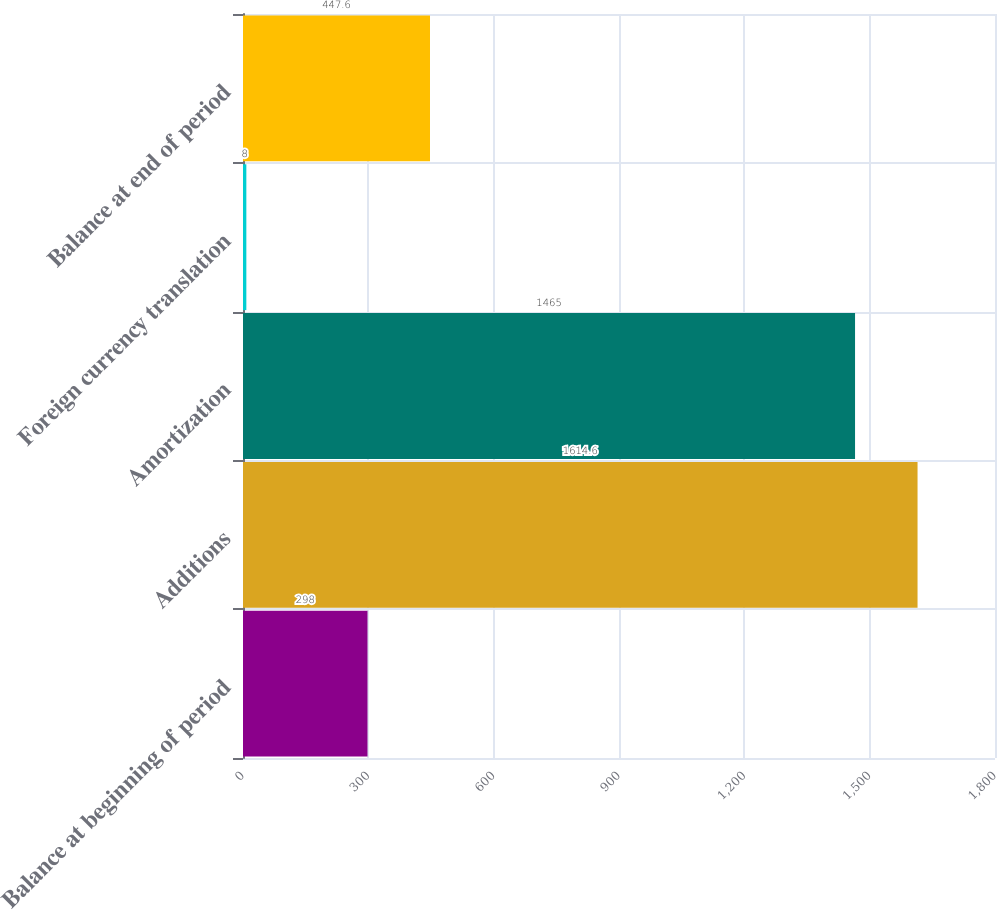Convert chart. <chart><loc_0><loc_0><loc_500><loc_500><bar_chart><fcel>Balance at beginning of period<fcel>Additions<fcel>Amortization<fcel>Foreign currency translation<fcel>Balance at end of period<nl><fcel>298<fcel>1614.6<fcel>1465<fcel>8<fcel>447.6<nl></chart> 